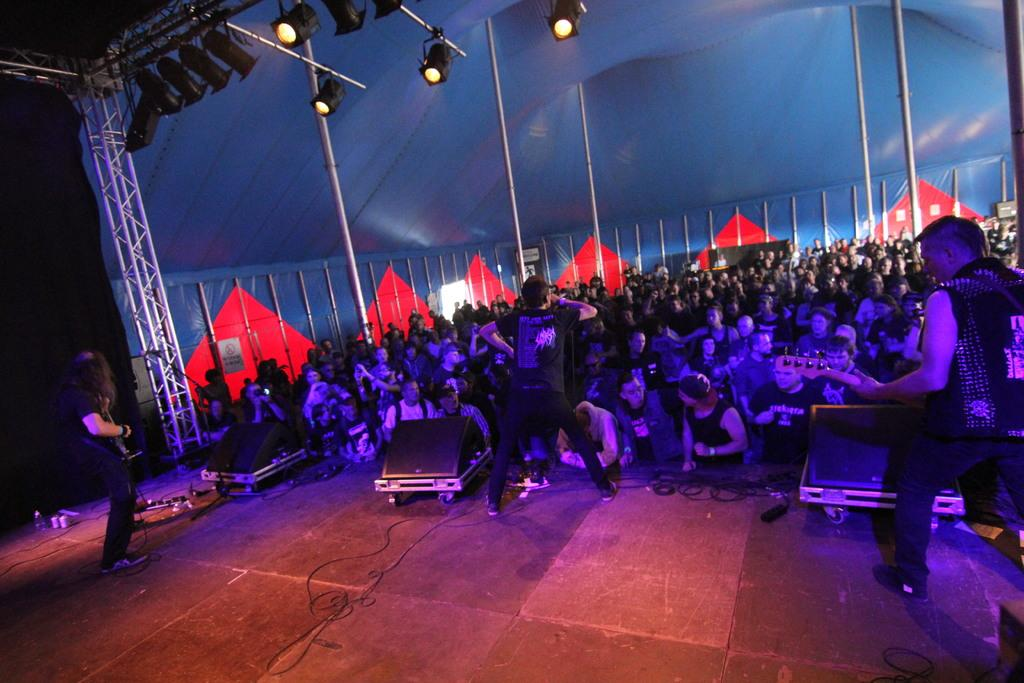How many people are present in the image? There are people in the image, but the exact number is not specified. What objects can be seen in the image besides people? There are poles, lights, speakers, and boards in the image. What are the people holding in the image? Two people are holding guitars in the image. How many cats and dogs are present in the image? There are no cats or dogs present in the image. 